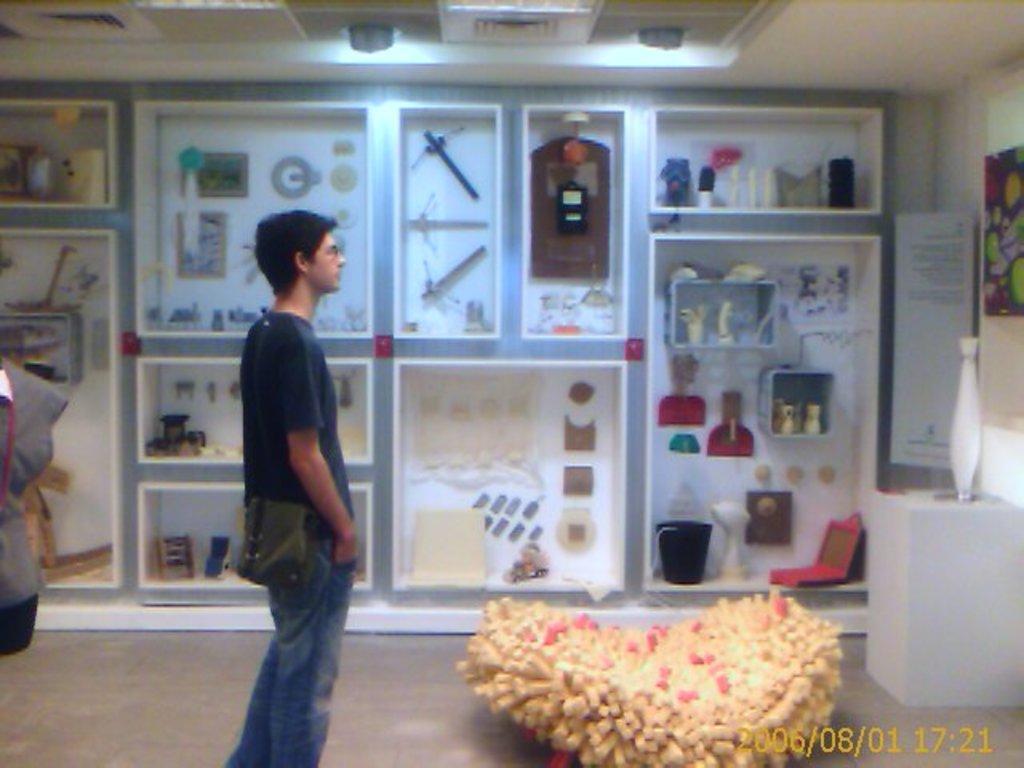Please provide a concise description of this image. In this picture we can see a person is standing and on the right side of the person there is an object. Behind the man there are some objects in the shelves and at the top there is a light. On the image there is a watermark. 